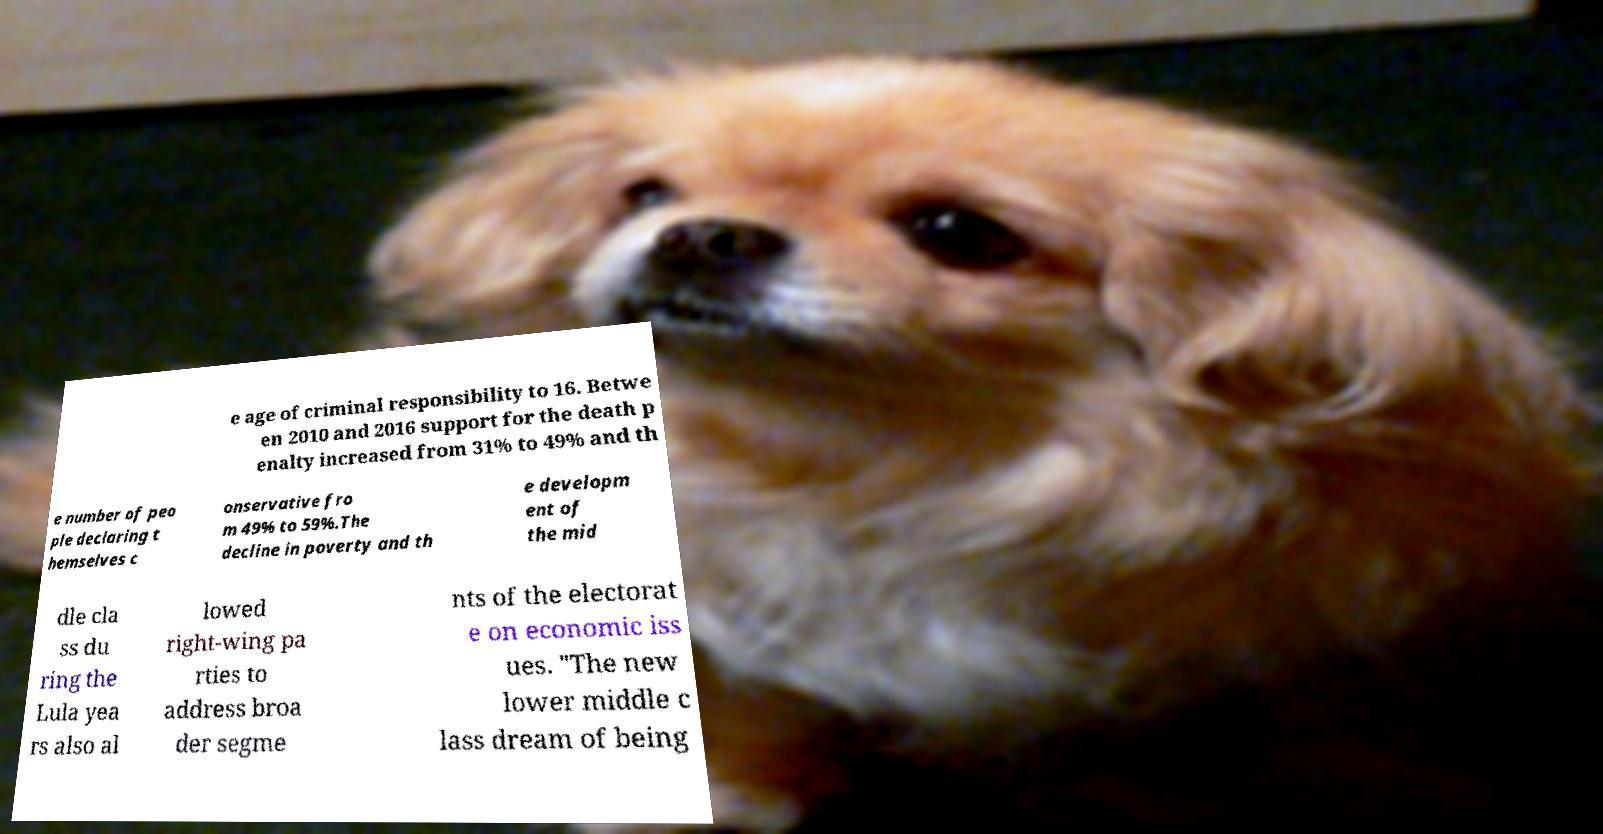Please read and relay the text visible in this image. What does it say? e age of criminal responsibility to 16. Betwe en 2010 and 2016 support for the death p enalty increased from 31% to 49% and th e number of peo ple declaring t hemselves c onservative fro m 49% to 59%.The decline in poverty and th e developm ent of the mid dle cla ss du ring the Lula yea rs also al lowed right-wing pa rties to address broa der segme nts of the electorat e on economic iss ues. "The new lower middle c lass dream of being 